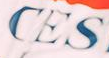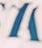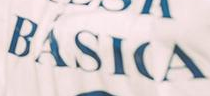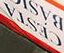Identify the words shown in these images in order, separated by a semicolon. CES; #; BÁSICA; CESTA 